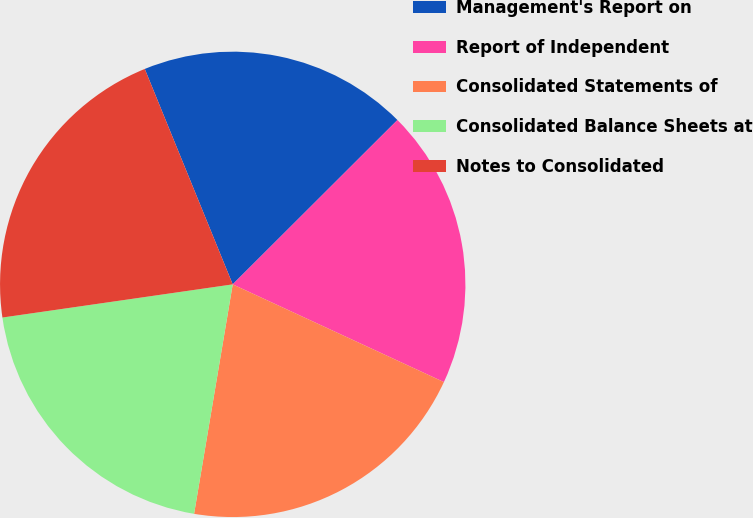Convert chart. <chart><loc_0><loc_0><loc_500><loc_500><pie_chart><fcel>Management's Report on<fcel>Report of Independent<fcel>Consolidated Statements of<fcel>Consolidated Balance Sheets at<fcel>Notes to Consolidated<nl><fcel>18.69%<fcel>19.38%<fcel>20.76%<fcel>20.07%<fcel>21.11%<nl></chart> 